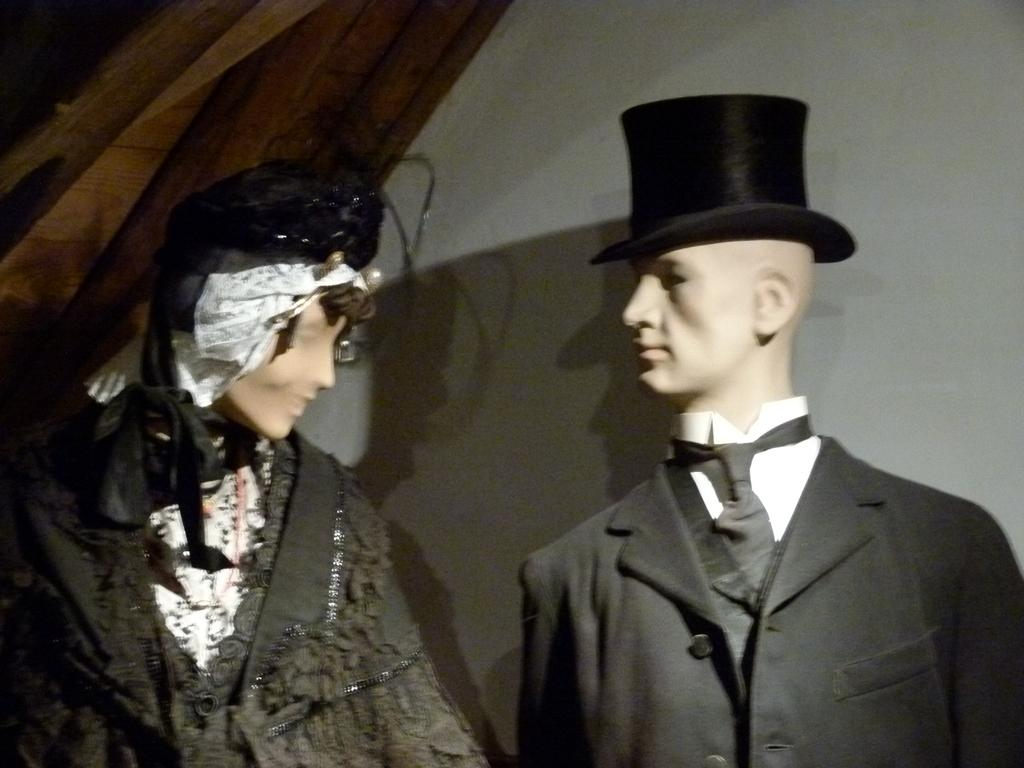What types of mannequins are present in the image? There is a mannequin of a man and a mannequin of a woman in the image. What can be seen in the background of the image? There is a wall in the background of the image. How many giants can be seen in the image? There are no giants present in the image; it features mannequins of a man and a woman. What type of weather is occurring in the image? The provided facts do not mention any weather conditions, so it cannot be determined from the image. 